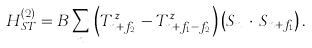<formula> <loc_0><loc_0><loc_500><loc_500>H _ { S T } ^ { ( 2 ) } = B \sum _ { n } \, \left ( T ^ { z } _ { { n } + { f } _ { 2 } } - T ^ { z } _ { { n } + { f } _ { 1 } - { f } _ { 2 } } \right ) \left ( { S } _ { n } \, \cdot \, { S } _ { { n } + { f } _ { 1 } } \right ) .</formula> 